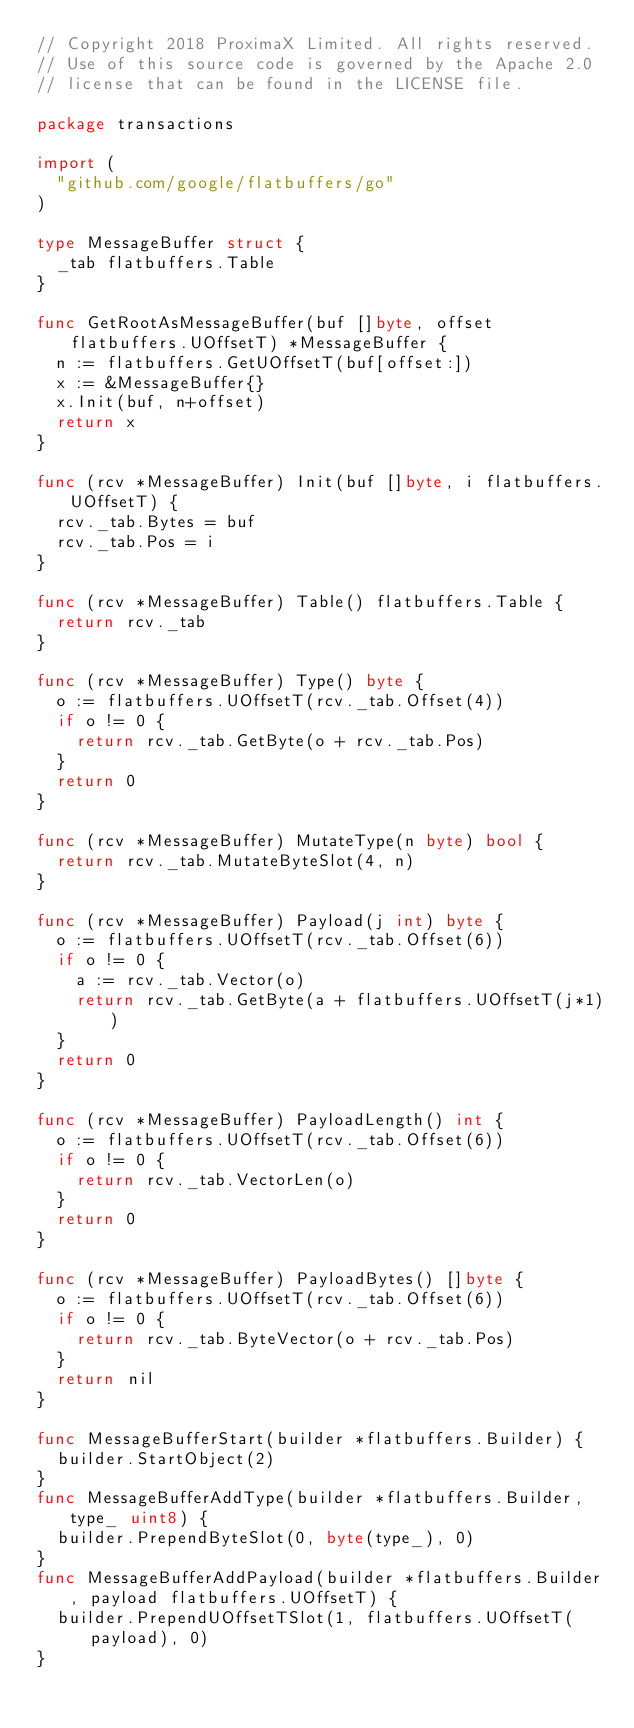Convert code to text. <code><loc_0><loc_0><loc_500><loc_500><_Go_>// Copyright 2018 ProximaX Limited. All rights reserved.
// Use of this source code is governed by the Apache 2.0
// license that can be found in the LICENSE file.

package transactions

import (
	"github.com/google/flatbuffers/go"
)

type MessageBuffer struct {
	_tab flatbuffers.Table
}

func GetRootAsMessageBuffer(buf []byte, offset flatbuffers.UOffsetT) *MessageBuffer {
	n := flatbuffers.GetUOffsetT(buf[offset:])
	x := &MessageBuffer{}
	x.Init(buf, n+offset)
	return x
}

func (rcv *MessageBuffer) Init(buf []byte, i flatbuffers.UOffsetT) {
	rcv._tab.Bytes = buf
	rcv._tab.Pos = i
}

func (rcv *MessageBuffer) Table() flatbuffers.Table {
	return rcv._tab
}

func (rcv *MessageBuffer) Type() byte {
	o := flatbuffers.UOffsetT(rcv._tab.Offset(4))
	if o != 0 {
		return rcv._tab.GetByte(o + rcv._tab.Pos)
	}
	return 0
}

func (rcv *MessageBuffer) MutateType(n byte) bool {
	return rcv._tab.MutateByteSlot(4, n)
}

func (rcv *MessageBuffer) Payload(j int) byte {
	o := flatbuffers.UOffsetT(rcv._tab.Offset(6))
	if o != 0 {
		a := rcv._tab.Vector(o)
		return rcv._tab.GetByte(a + flatbuffers.UOffsetT(j*1))
	}
	return 0
}

func (rcv *MessageBuffer) PayloadLength() int {
	o := flatbuffers.UOffsetT(rcv._tab.Offset(6))
	if o != 0 {
		return rcv._tab.VectorLen(o)
	}
	return 0
}

func (rcv *MessageBuffer) PayloadBytes() []byte {
	o := flatbuffers.UOffsetT(rcv._tab.Offset(6))
	if o != 0 {
		return rcv._tab.ByteVector(o + rcv._tab.Pos)
	}
	return nil
}

func MessageBufferStart(builder *flatbuffers.Builder) {
	builder.StartObject(2)
}
func MessageBufferAddType(builder *flatbuffers.Builder, type_ uint8) {
	builder.PrependByteSlot(0, byte(type_), 0)
}
func MessageBufferAddPayload(builder *flatbuffers.Builder, payload flatbuffers.UOffsetT) {
	builder.PrependUOffsetTSlot(1, flatbuffers.UOffsetT(payload), 0)
}
</code> 